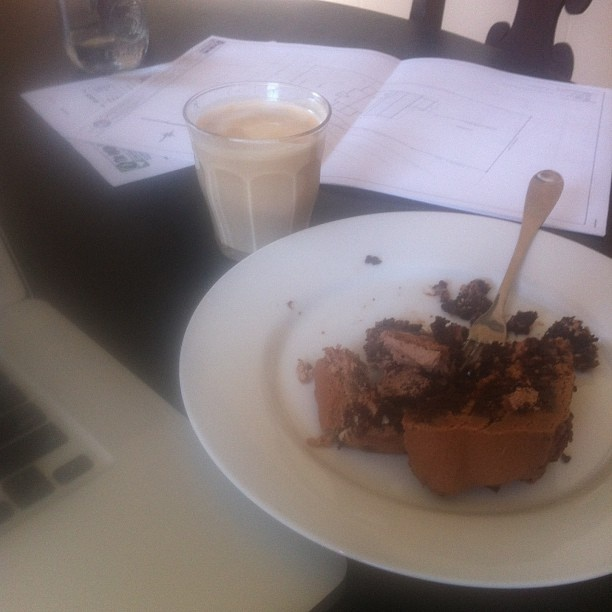Describe the objects in this image and their specific colors. I can see dining table in lightgray, darkgray, lavender, black, and gray tones, laptop in maroon and gray tones, cake in maroon, black, and brown tones, cup in maroon, darkgray, lavender, and gray tones, and chair in maroon, darkgray, gray, and black tones in this image. 